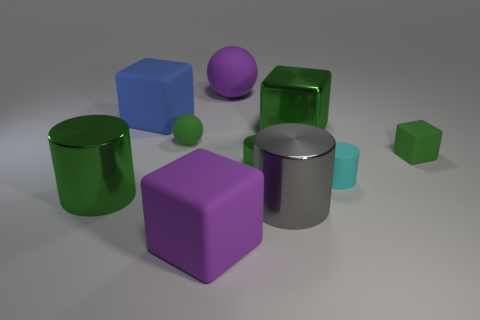Subtract 1 cylinders. How many cylinders are left? 3 Subtract all balls. How many objects are left? 8 Subtract all cyan matte spheres. Subtract all metal cylinders. How many objects are left? 7 Add 6 big metal things. How many big metal things are left? 9 Add 5 green cylinders. How many green cylinders exist? 7 Subtract 0 red cylinders. How many objects are left? 10 